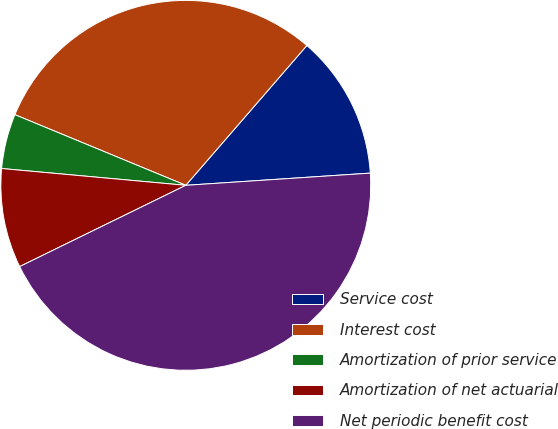Convert chart to OTSL. <chart><loc_0><loc_0><loc_500><loc_500><pie_chart><fcel>Service cost<fcel>Interest cost<fcel>Amortization of prior service<fcel>Amortization of net actuarial<fcel>Net periodic benefit cost<nl><fcel>12.59%<fcel>30.12%<fcel>4.79%<fcel>8.69%<fcel>43.81%<nl></chart> 